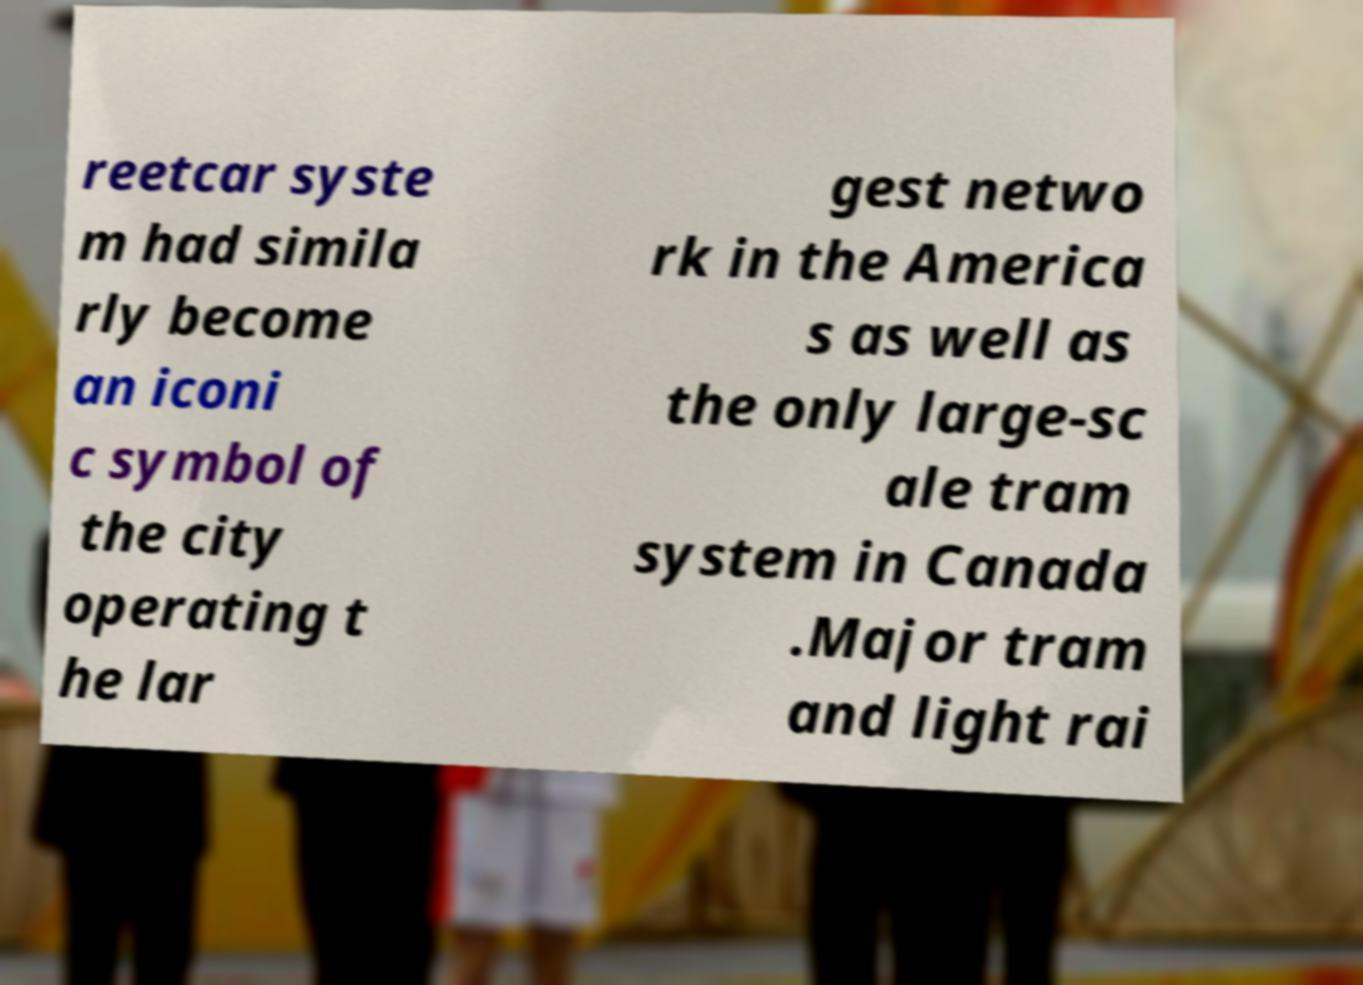Please identify and transcribe the text found in this image. reetcar syste m had simila rly become an iconi c symbol of the city operating t he lar gest netwo rk in the America s as well as the only large-sc ale tram system in Canada .Major tram and light rai 